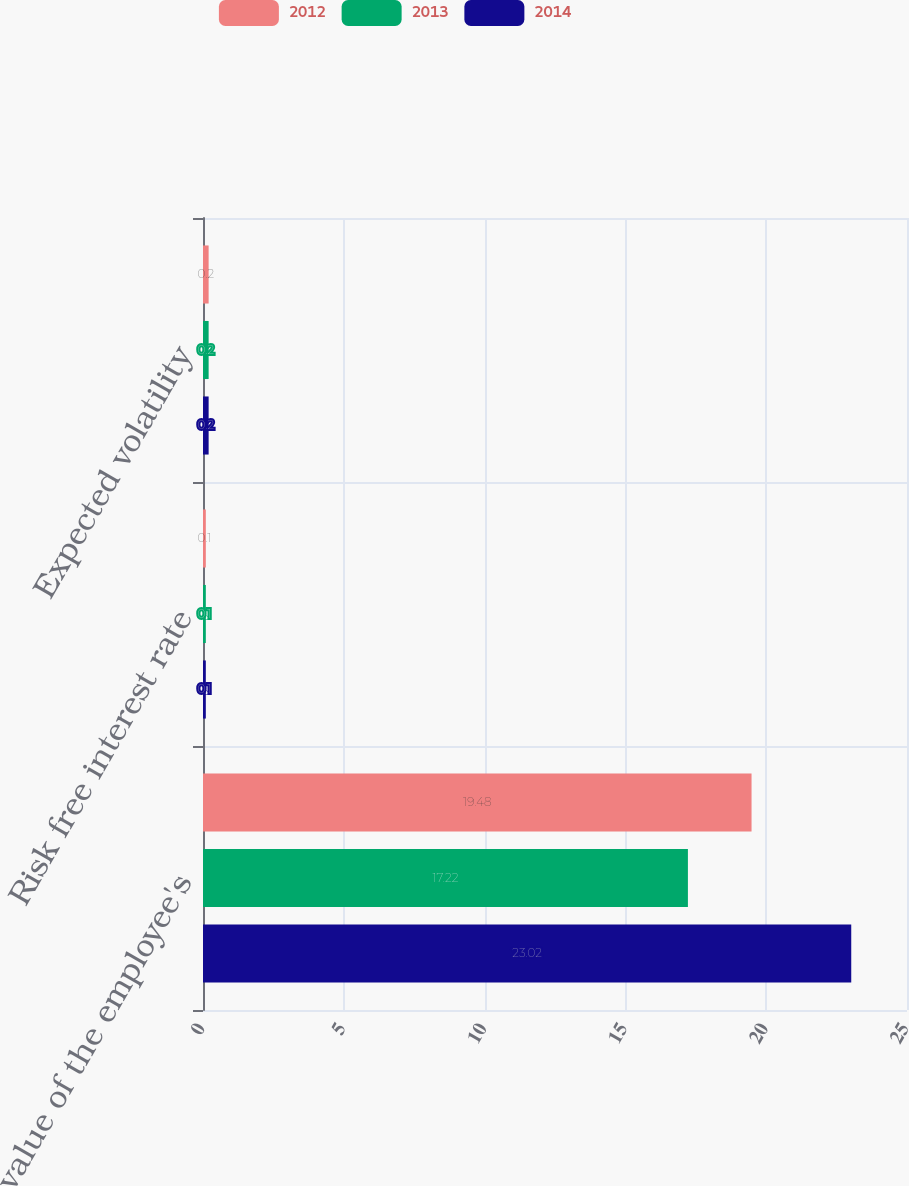<chart> <loc_0><loc_0><loc_500><loc_500><stacked_bar_chart><ecel><fcel>Fair value of the employee's<fcel>Risk free interest rate<fcel>Expected volatility<nl><fcel>2012<fcel>19.48<fcel>0.1<fcel>0.2<nl><fcel>2013<fcel>17.22<fcel>0.1<fcel>0.2<nl><fcel>2014<fcel>23.02<fcel>0.1<fcel>0.2<nl></chart> 